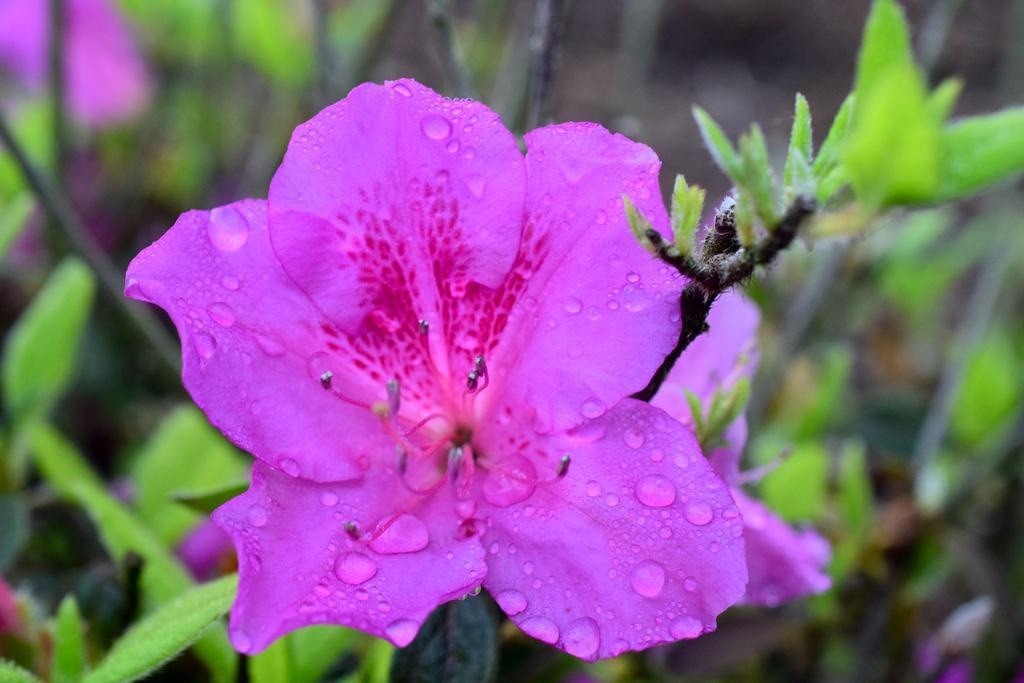Please provide a concise description of this image. In front of the image there is a flower with water droplets on it and there are stems and leaves, behind the flower there are leaves, flowers and stems. 